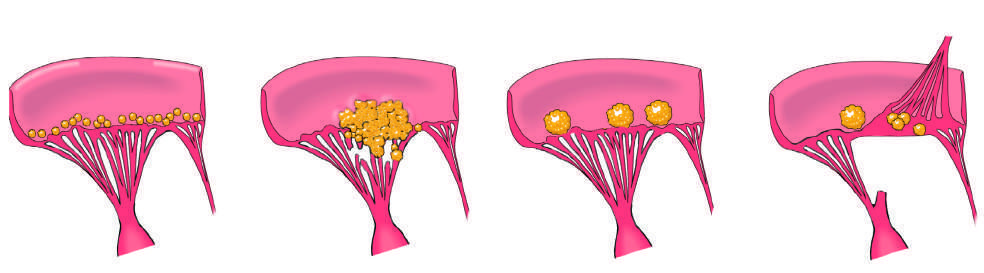do cohesive tumor in retina heal with scarring?
Answer the question using a single word or phrase. No 